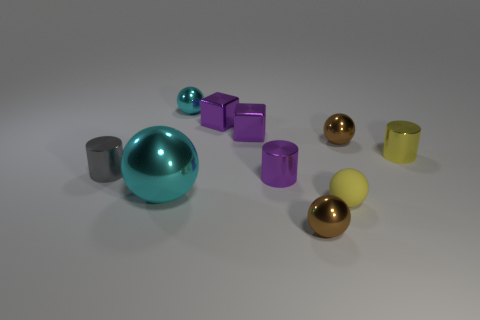Subtract all cyan cylinders. How many brown balls are left? 2 Subtract all yellow balls. How many balls are left? 4 Subtract all yellow balls. How many balls are left? 4 Subtract all green spheres. Subtract all brown blocks. How many spheres are left? 5 Subtract all cylinders. How many objects are left? 7 Add 3 small cyan metallic things. How many small cyan metallic things are left? 4 Add 10 small purple metallic balls. How many small purple metallic balls exist? 10 Subtract 1 yellow cylinders. How many objects are left? 9 Subtract all small rubber spheres. Subtract all gray shiny cylinders. How many objects are left? 8 